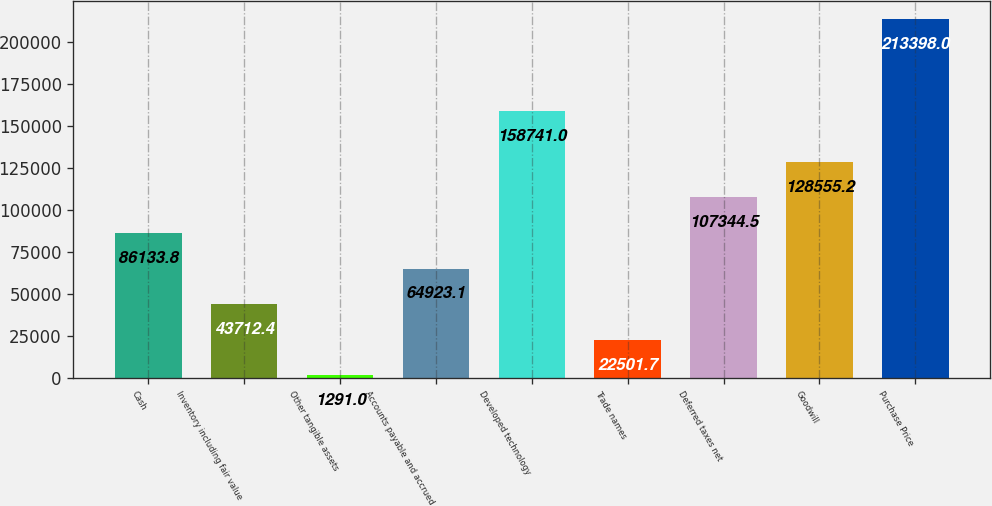<chart> <loc_0><loc_0><loc_500><loc_500><bar_chart><fcel>Cash<fcel>Inventory including fair value<fcel>Other tangible assets<fcel>Accounts payable and accrued<fcel>Developed technology<fcel>Trade names<fcel>Deferred taxes net<fcel>Goodwill<fcel>Purchase Price<nl><fcel>86133.8<fcel>43712.4<fcel>1291<fcel>64923.1<fcel>158741<fcel>22501.7<fcel>107344<fcel>128555<fcel>213398<nl></chart> 